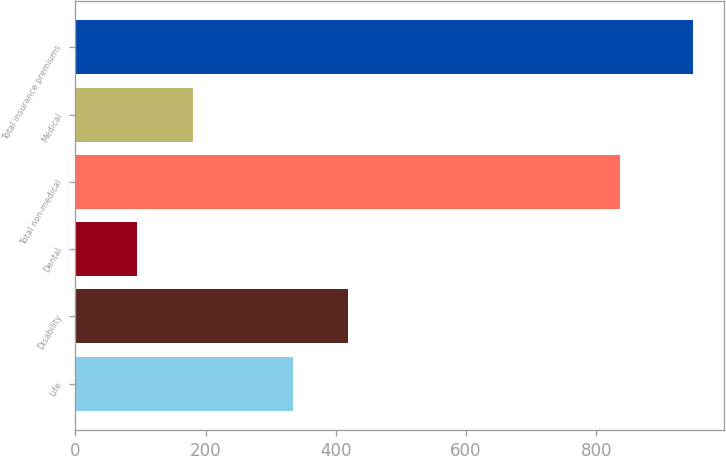Convert chart to OTSL. <chart><loc_0><loc_0><loc_500><loc_500><bar_chart><fcel>Life<fcel>Disability<fcel>Dental<fcel>Total non-medical<fcel>Medical<fcel>Total insurance premiums<nl><fcel>334<fcel>419.4<fcel>95<fcel>836<fcel>180.4<fcel>949<nl></chart> 